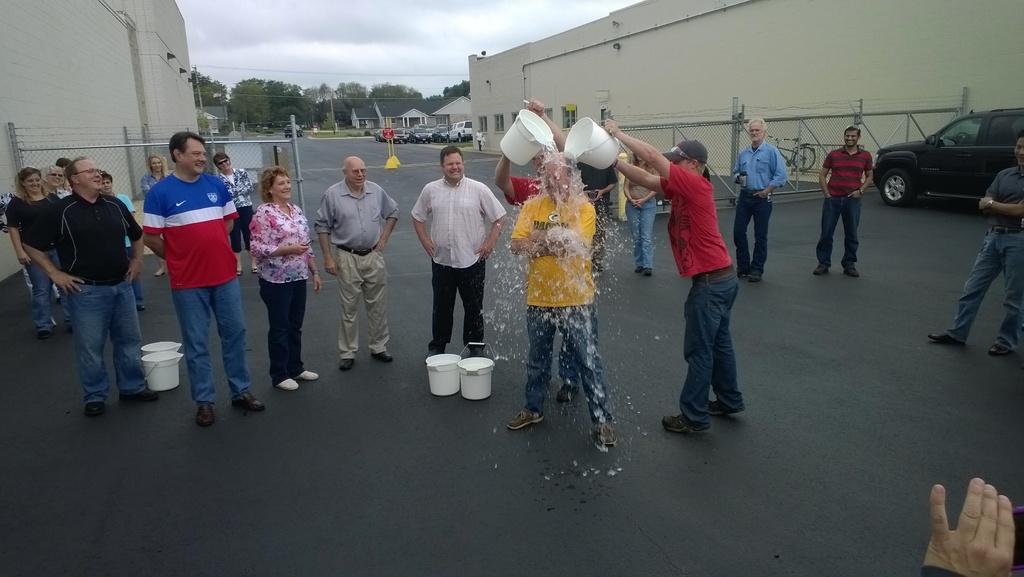Could you give a brief overview of what you see in this image? In this image we can see these two persons are holding buckets and pouring the water on this person and these people are standing on the road. Here we can see few buckets, vehicles parked here, the fence, houses, wires, poles, trees and the cloudy sky in the background. 